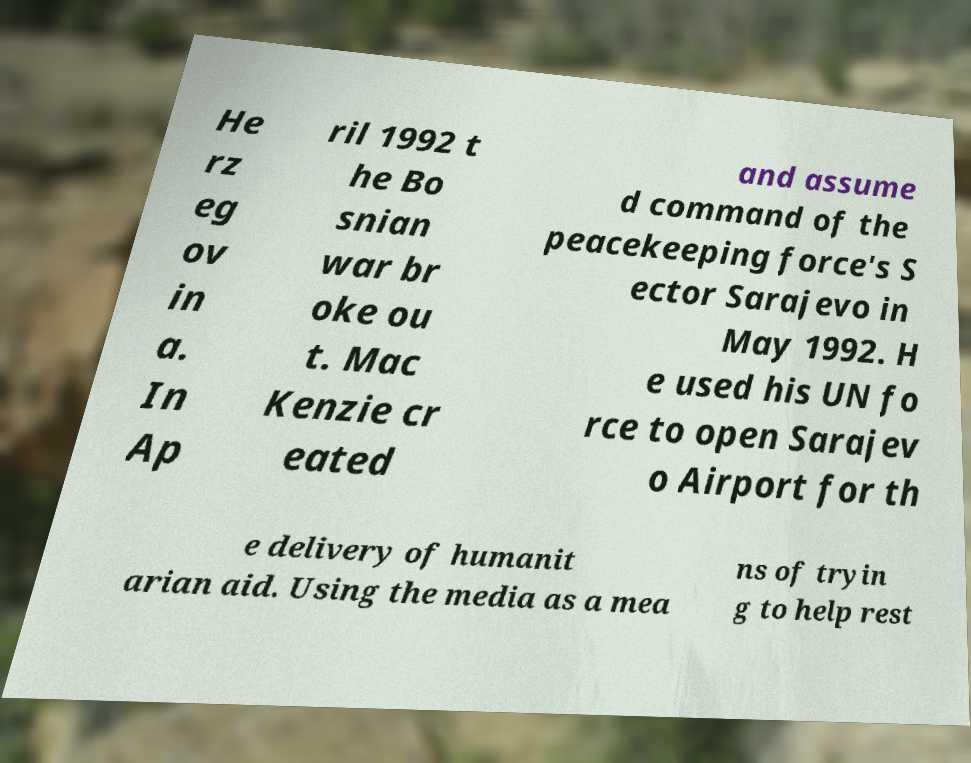Can you accurately transcribe the text from the provided image for me? He rz eg ov in a. In Ap ril 1992 t he Bo snian war br oke ou t. Mac Kenzie cr eated and assume d command of the peacekeeping force's S ector Sarajevo in May 1992. H e used his UN fo rce to open Sarajev o Airport for th e delivery of humanit arian aid. Using the media as a mea ns of tryin g to help rest 